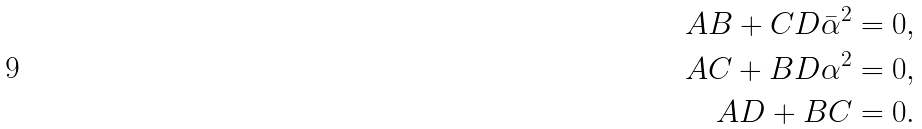<formula> <loc_0><loc_0><loc_500><loc_500>A B + C D \bar { \alpha } ^ { 2 } & = 0 , \\ A C + B D \alpha ^ { 2 } & = 0 , \\ A D + B C & = 0 .</formula> 